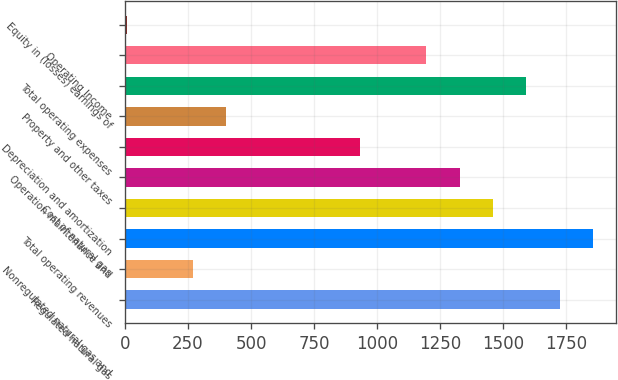Convert chart to OTSL. <chart><loc_0><loc_0><loc_500><loc_500><bar_chart><fcel>Regulated natural gas<fcel>Nonregulated natural gas and<fcel>Total operating revenues<fcel>Cost of natural gas<fcel>Operation maintenance and<fcel>Depreciation and amortization<fcel>Property and other taxes<fcel>Total operating expenses<fcel>Operating Income<fcel>Equity in (losses) earnings of<nl><fcel>1724.6<fcel>270.4<fcel>1856.8<fcel>1460.2<fcel>1328<fcel>931.4<fcel>402.6<fcel>1592.4<fcel>1195.8<fcel>6<nl></chart> 